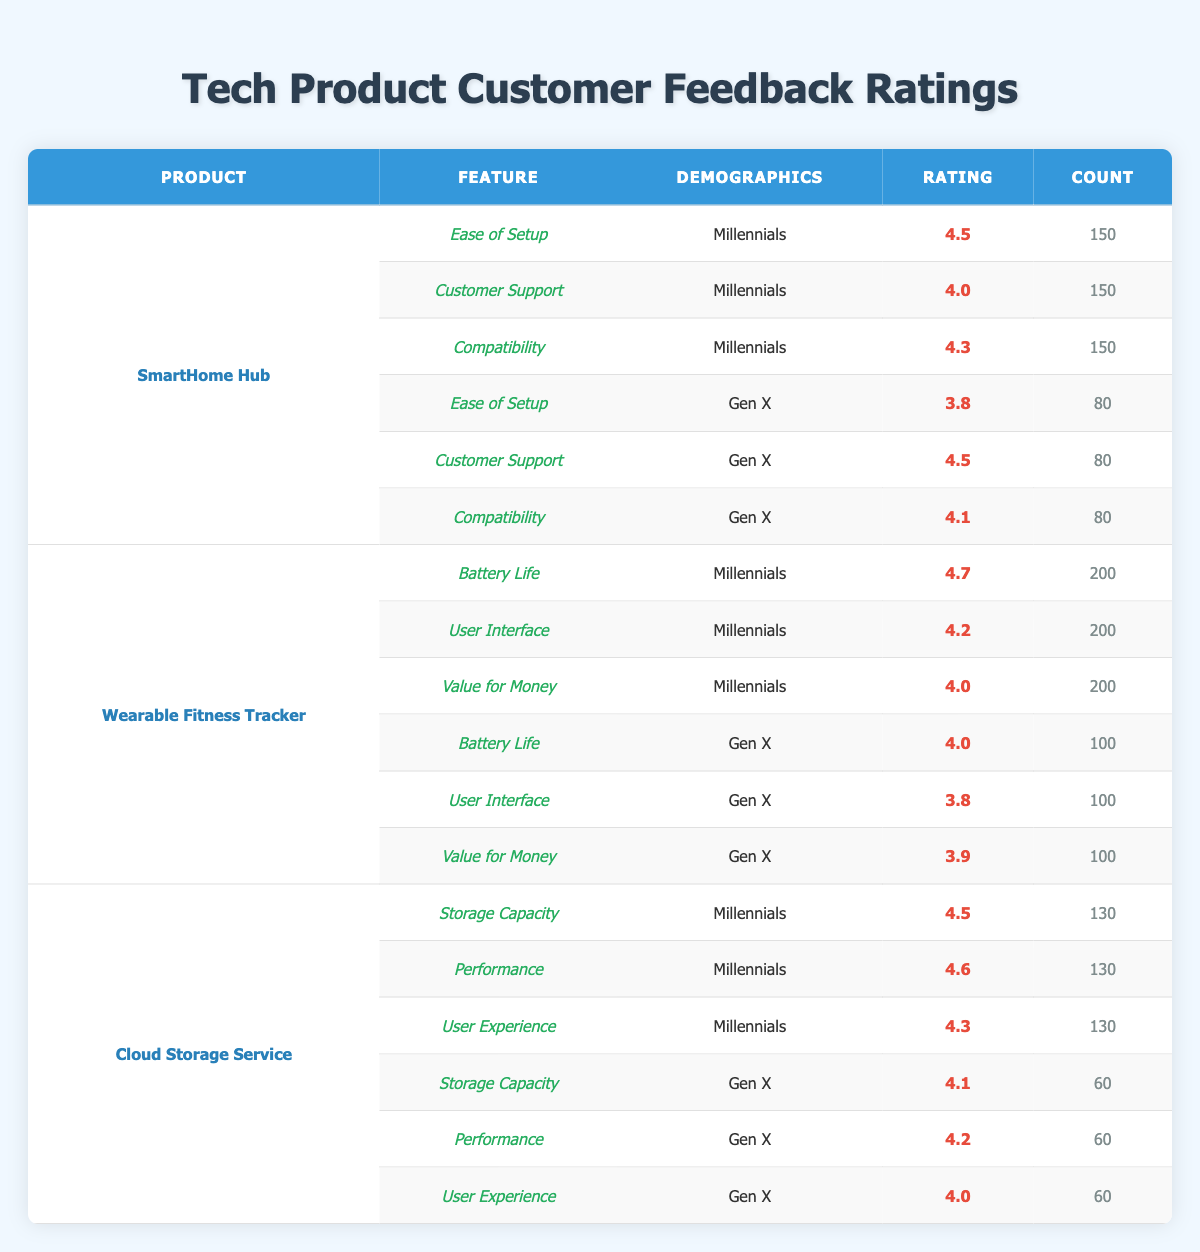What is the highest rating given to the "Ease of Setup" feature for the "SmartHome Hub"? The "Ease of Setup" feature for "SmartHome Hub" received ratings from two demographic groups: Millennials (4.5) and Gen X (3.8). The highest rating among these is 4.5 from Millennials.
Answer: 4.5 Which product received the lowest rating for the "User Interface" feature? The "User Interface" feature was rated for two products: the "Wearable Fitness Tracker" received 4.2 from Millennials and 3.8 from Gen X, while the "Cloud Storage Service" received an average rating of 4.3 from Millennials and 4.0 from Gen X. Therefore, the lowest rating for "User Interface" is 3.8 from Gen X for the "Wearable Fitness Tracker."
Answer: 3.8 What is the average rating for Millennials across all features of the "Cloud Storage Service"? The ratings for Millennials' features of "Cloud Storage Service" are: Storage Capacity (4.5), Performance (4.6), and User Experience (4.3). Adding these ratings gives 4.5 + 4.6 + 4.3 = 13.4. Dividing by the number of features (3) results in an average rating of 13.4 / 3 = 4.47.
Answer: 4.47 Did Millennials rate "Battery Life" for "Wearable Fitness Tracker" higher than Gen X? Millennials rated "Battery Life" for "Wearable Fitness Tracker" at 4.7, while Gen X rated it at 4.0. Since 4.7 is greater than 4.0, Millennials did rate it higher.
Answer: Yes Which demographic provided the highest count of ratings for "Value for Money" on the "Wearable Fitness Tracker"? The count for "Value for Money" on the "Wearable Fitness Tracker" is 200 for Millennials and 100 for Gen X. Since 200 is greater than 100, the Millennials provided the highest count of ratings.
Answer: Millennials What rating did "Customer Support" get from Gen X for the "SmartHome Hub"? The table shows that "Customer Support" received a rating of 4.5 from Gen X for the "SmartHome Hub."
Answer: 4.5 What is the difference in rating for "Compatibility" between Millennials and Gen X for the "SmartHome Hub"? The rating for "Compatibility" from Millennials is 4.3 and from Gen X is 4.1. The difference is calculated by subtracting Gen X rating from Millennial rating, which results in 4.3 - 4.1 = 0.2.
Answer: 0.2 How many total ratings were collected for the "Battery Life" feature of "Wearable Fitness Tracker"? The total ratings for "Battery Life" include 200 from Millennials and 100 from Gen X. Adding these amounts gives 200 + 100 = 300 total ratings collected for this feature.
Answer: 300 What demographic rated "Performance" for the "Cloud Storage Service" higher? Millennials rated "Performance" for "Cloud Storage Service" at 4.6, while Gen X rated it at 4.2. Since 4.6 is greater than 4.2, Millennials rated it higher.
Answer: Millennials 